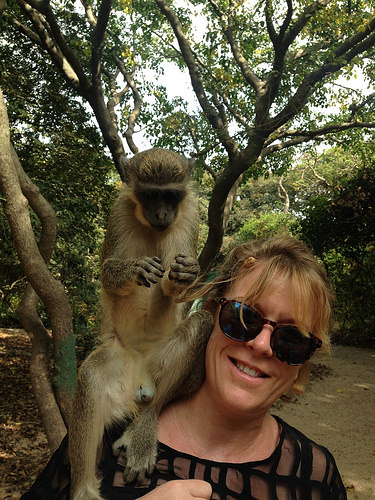<image>
Is there a monkey on the girl? Yes. Looking at the image, I can see the monkey is positioned on top of the girl, with the girl providing support. Is the monkey on the tree? No. The monkey is not positioned on the tree. They may be near each other, but the monkey is not supported by or resting on top of the tree. Is the tree behind the monkey? Yes. From this viewpoint, the tree is positioned behind the monkey, with the monkey partially or fully occluding the tree. 